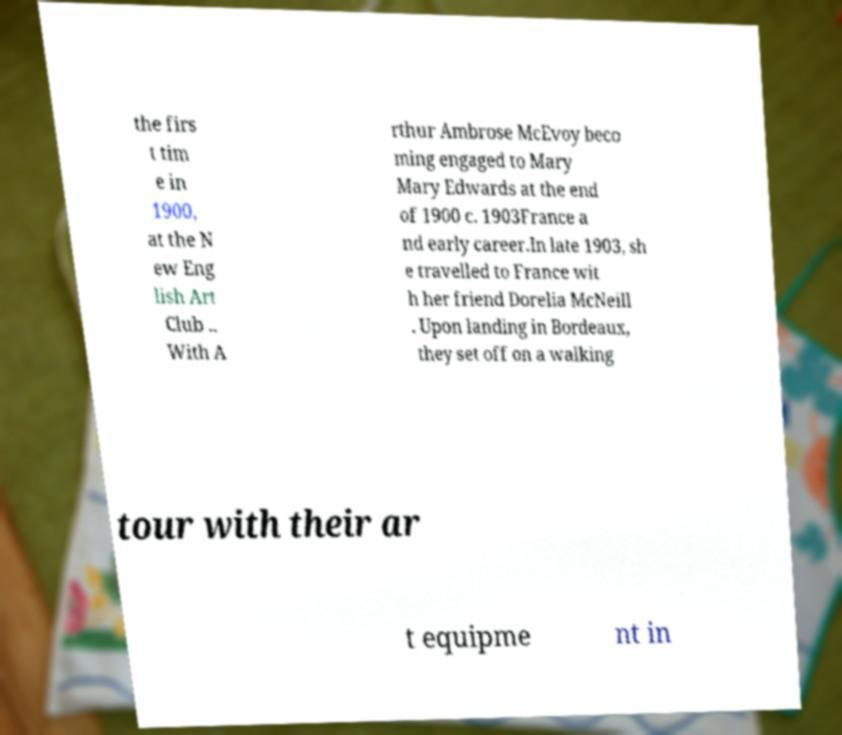What messages or text are displayed in this image? I need them in a readable, typed format. the firs t tim e in 1900, at the N ew Eng lish Art Club .. With A rthur Ambrose McEvoy beco ming engaged to Mary Mary Edwards at the end of 1900 c. 1903France a nd early career.In late 1903, sh e travelled to France wit h her friend Dorelia McNeill . Upon landing in Bordeaux, they set off on a walking tour with their ar t equipme nt in 